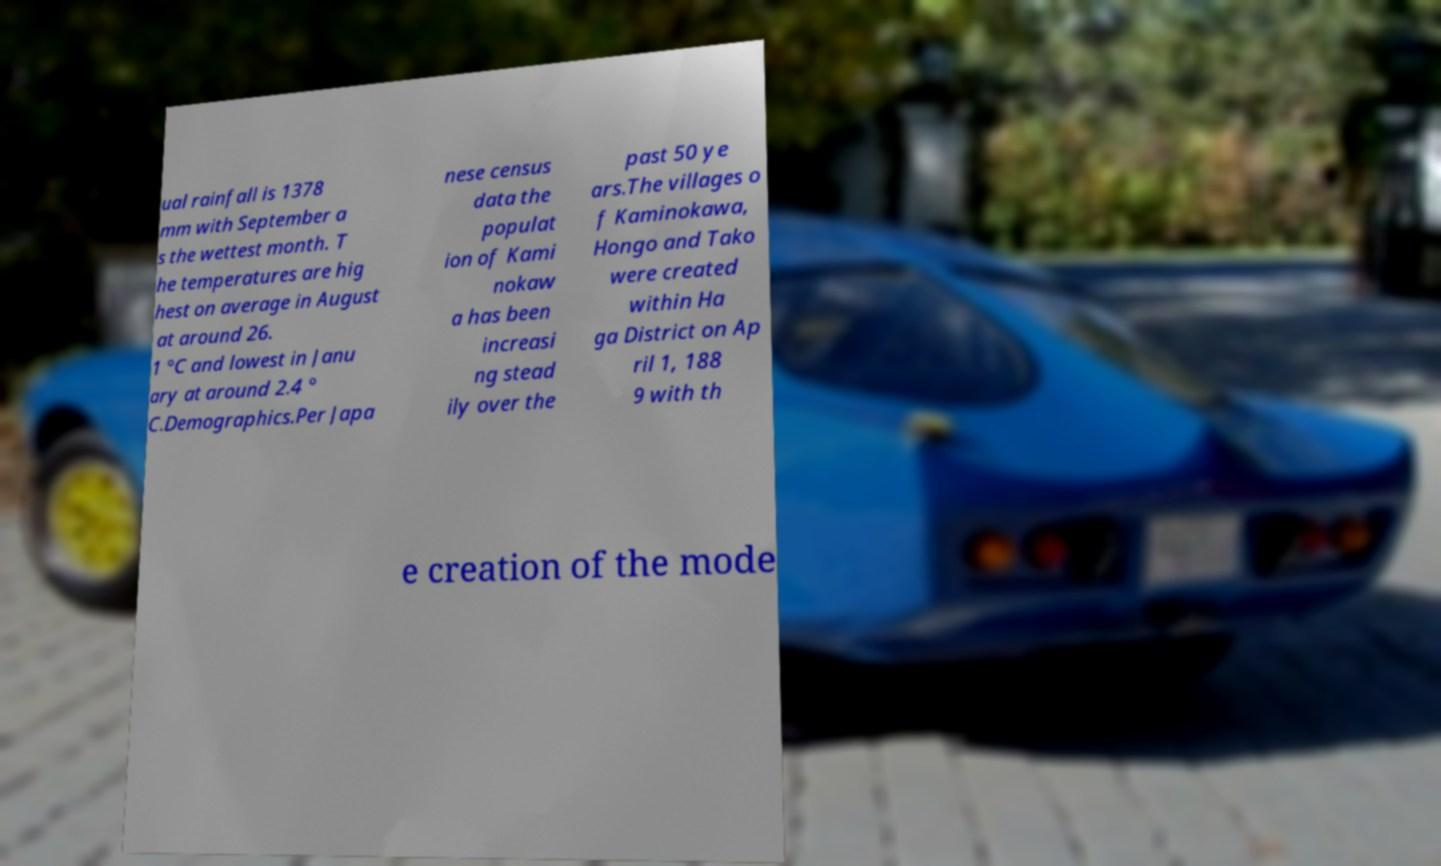Can you accurately transcribe the text from the provided image for me? ual rainfall is 1378 mm with September a s the wettest month. T he temperatures are hig hest on average in August at around 26. 1 °C and lowest in Janu ary at around 2.4 ° C.Demographics.Per Japa nese census data the populat ion of Kami nokaw a has been increasi ng stead ily over the past 50 ye ars.The villages o f Kaminokawa, Hongo and Tako were created within Ha ga District on Ap ril 1, 188 9 with th e creation of the mode 